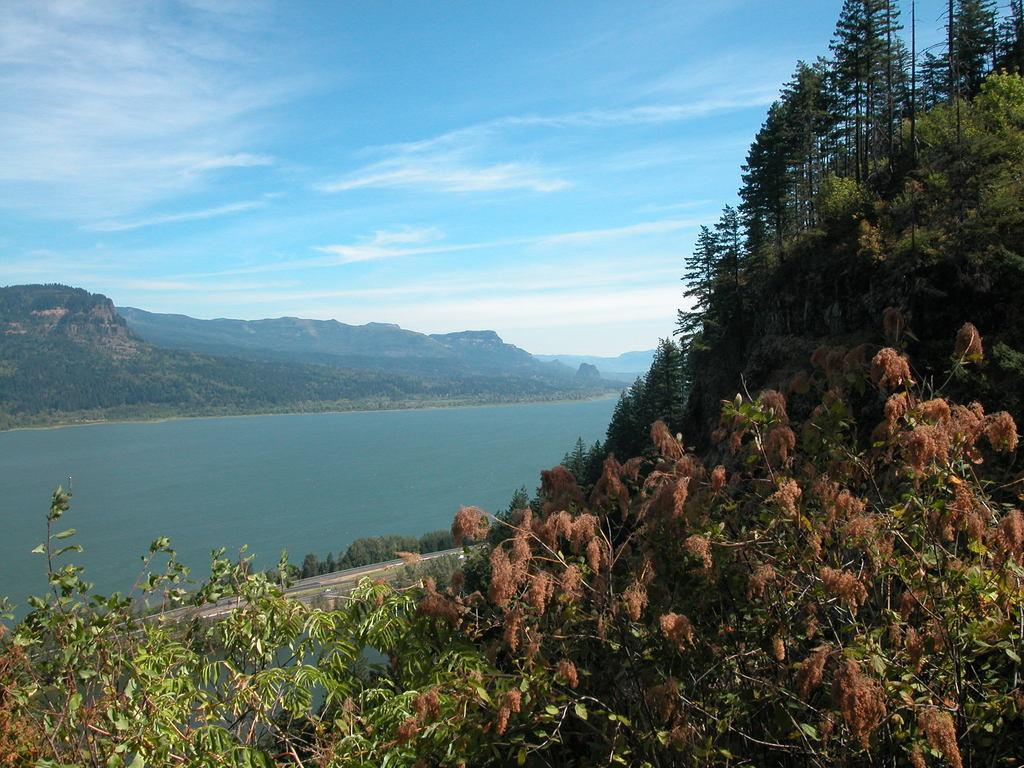What type of vegetation can be seen in the image? There are trees in the image. What natural element is visible in the image? There is water visible in the image. What can be seen in the background of the image? There are hills and the sky visible in the background of the image. What is the condition of the sky in the image? Clouds are present in the sky. What type of volleyball competition is taking place in the image? There is no volleyball competition present in the image; it features trees, water, hills, and a sky with clouds. Can you see any ghosts participating in the competition in the image? There are no ghosts present in the image. 